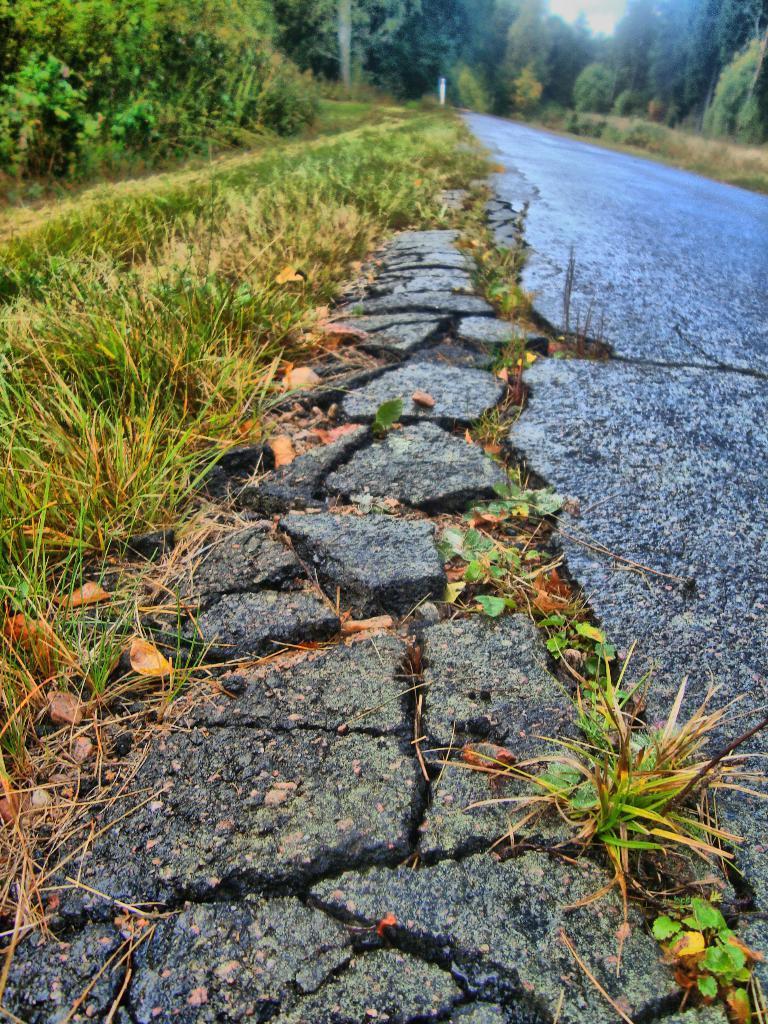How would you summarize this image in a sentence or two? In this picture we can see some grass on the ground on the left side. There are few trees on top right. We can see a path. 